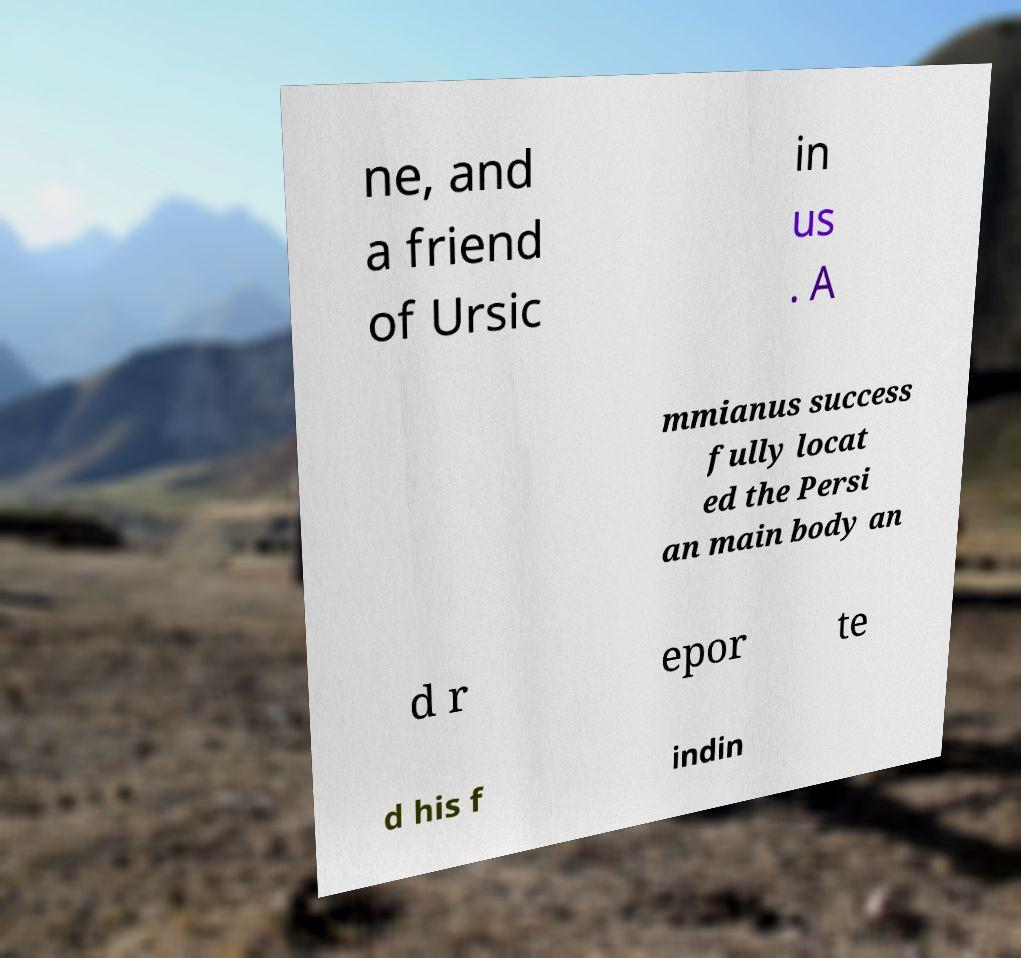There's text embedded in this image that I need extracted. Can you transcribe it verbatim? ne, and a friend of Ursic in us . A mmianus success fully locat ed the Persi an main body an d r epor te d his f indin 